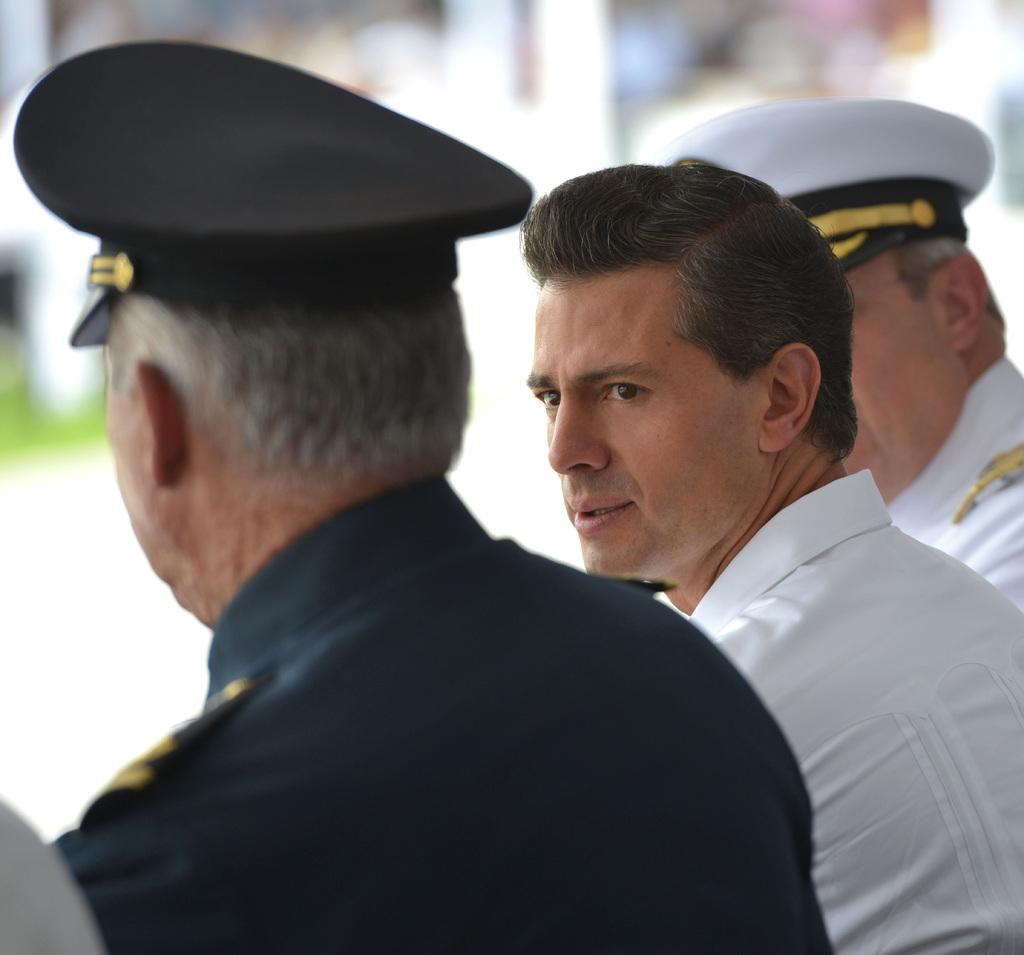How many people are in the image? There are three men in the image. What is the direction of the middle person's gaze? The middle person is looking towards his left. Can you describe the background of the men in the image? The background of the men is blurred. What type of potato is being used as a prop in the image? There is no potato present in the image. Can you describe the detail on the dock in the image? There is no dock present in the image. 